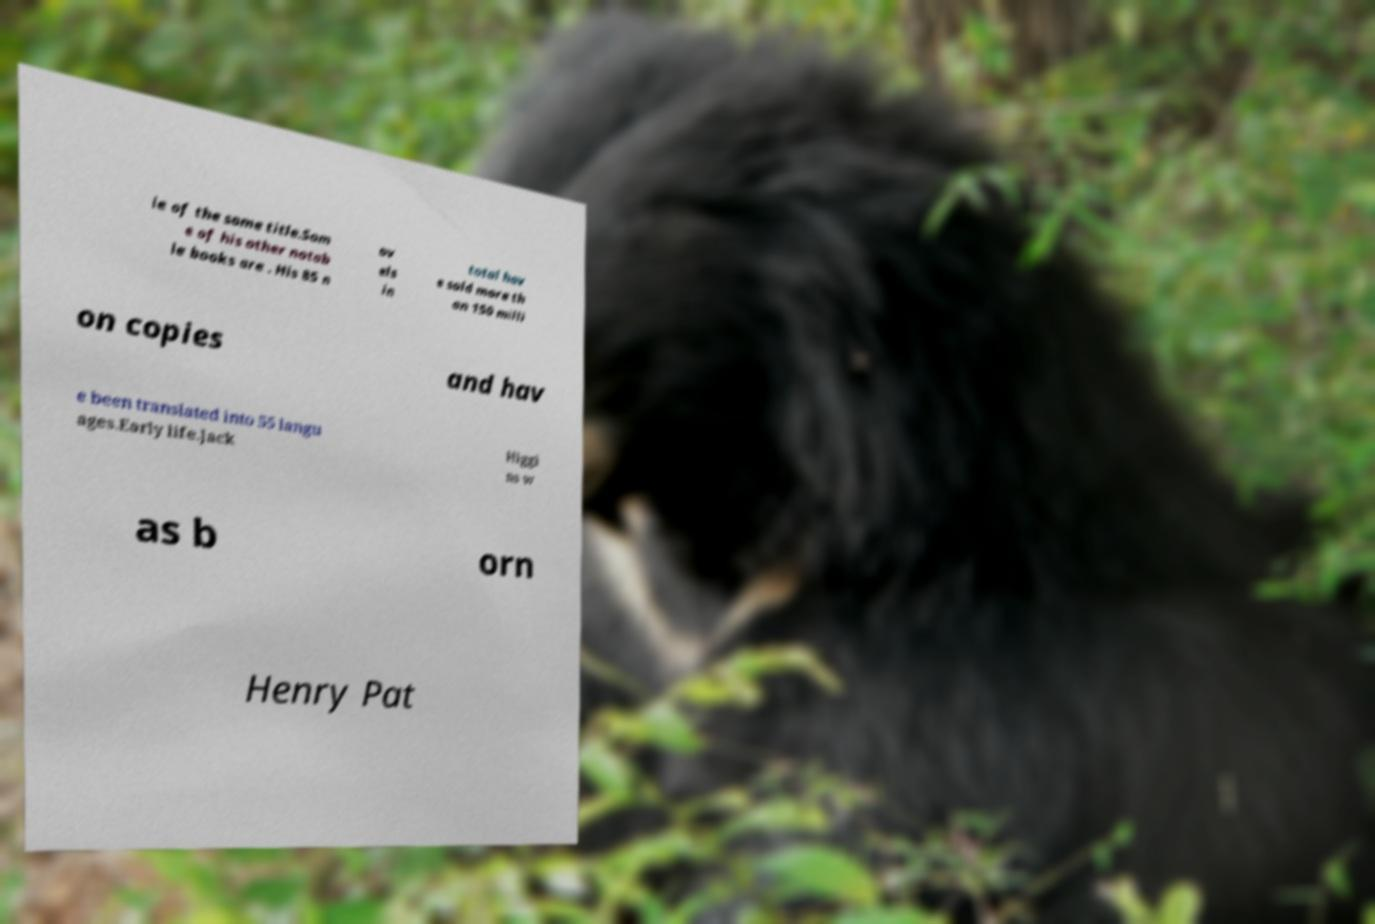Please read and relay the text visible in this image. What does it say? ie of the same title.Som e of his other notab le books are . His 85 n ov els in total hav e sold more th an 150 milli on copies and hav e been translated into 55 langu ages.Early life.Jack Higgi ns w as b orn Henry Pat 